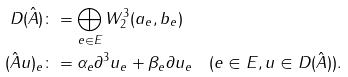Convert formula to latex. <formula><loc_0><loc_0><loc_500><loc_500>D ( \hat { A } ) & \colon = \bigoplus _ { e \in E } W _ { 2 } ^ { 3 } ( a _ { e } , b _ { e } ) \\ ( \hat { A } u ) _ { e } & \colon = \alpha _ { e } \partial ^ { 3 } u _ { e } + \beta _ { e } \partial u _ { e } \quad ( e \in E , u \in D ( \hat { A } ) ) .</formula> 